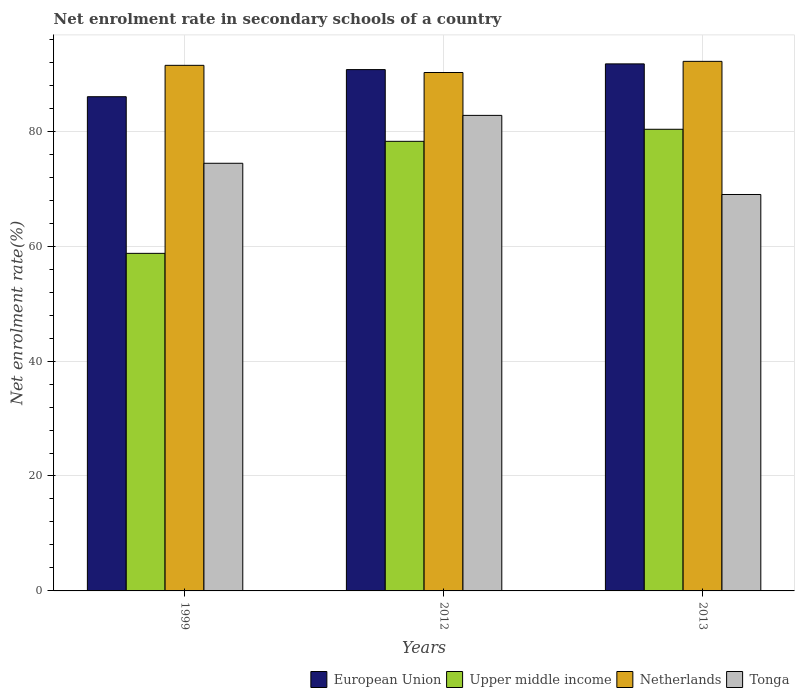How many different coloured bars are there?
Provide a short and direct response. 4. Are the number of bars per tick equal to the number of legend labels?
Make the answer very short. Yes. Are the number of bars on each tick of the X-axis equal?
Your answer should be compact. Yes. How many bars are there on the 3rd tick from the right?
Ensure brevity in your answer.  4. What is the label of the 1st group of bars from the left?
Provide a succinct answer. 1999. What is the net enrolment rate in secondary schools in Tonga in 2012?
Keep it short and to the point. 82.76. Across all years, what is the maximum net enrolment rate in secondary schools in European Union?
Keep it short and to the point. 91.72. Across all years, what is the minimum net enrolment rate in secondary schools in Tonga?
Make the answer very short. 68.99. In which year was the net enrolment rate in secondary schools in Netherlands maximum?
Offer a very short reply. 2013. In which year was the net enrolment rate in secondary schools in European Union minimum?
Give a very brief answer. 1999. What is the total net enrolment rate in secondary schools in Tonga in the graph?
Give a very brief answer. 226.17. What is the difference between the net enrolment rate in secondary schools in Netherlands in 2012 and that in 2013?
Your response must be concise. -1.94. What is the difference between the net enrolment rate in secondary schools in European Union in 2012 and the net enrolment rate in secondary schools in Upper middle income in 2013?
Give a very brief answer. 10.38. What is the average net enrolment rate in secondary schools in Upper middle income per year?
Offer a very short reply. 72.44. In the year 2013, what is the difference between the net enrolment rate in secondary schools in Tonga and net enrolment rate in secondary schools in Netherlands?
Give a very brief answer. -23.17. What is the ratio of the net enrolment rate in secondary schools in Tonga in 2012 to that in 2013?
Give a very brief answer. 1.2. Is the net enrolment rate in secondary schools in Tonga in 2012 less than that in 2013?
Offer a terse response. No. Is the difference between the net enrolment rate in secondary schools in Tonga in 2012 and 2013 greater than the difference between the net enrolment rate in secondary schools in Netherlands in 2012 and 2013?
Your answer should be very brief. Yes. What is the difference between the highest and the second highest net enrolment rate in secondary schools in European Union?
Your response must be concise. 0.99. What is the difference between the highest and the lowest net enrolment rate in secondary schools in Tonga?
Your answer should be very brief. 13.77. In how many years, is the net enrolment rate in secondary schools in Tonga greater than the average net enrolment rate in secondary schools in Tonga taken over all years?
Offer a very short reply. 1. What does the 1st bar from the right in 2013 represents?
Make the answer very short. Tonga. How many years are there in the graph?
Make the answer very short. 3. What is the difference between two consecutive major ticks on the Y-axis?
Ensure brevity in your answer.  20. Does the graph contain grids?
Your response must be concise. Yes. What is the title of the graph?
Your answer should be very brief. Net enrolment rate in secondary schools of a country. Does "Kyrgyz Republic" appear as one of the legend labels in the graph?
Provide a succinct answer. No. What is the label or title of the Y-axis?
Offer a terse response. Net enrolment rate(%). What is the Net enrolment rate(%) of European Union in 1999?
Your response must be concise. 86.01. What is the Net enrolment rate(%) of Upper middle income in 1999?
Provide a succinct answer. 58.75. What is the Net enrolment rate(%) of Netherlands in 1999?
Keep it short and to the point. 91.47. What is the Net enrolment rate(%) in Tonga in 1999?
Provide a short and direct response. 74.42. What is the Net enrolment rate(%) of European Union in 2012?
Keep it short and to the point. 90.73. What is the Net enrolment rate(%) in Upper middle income in 2012?
Your answer should be very brief. 78.24. What is the Net enrolment rate(%) in Netherlands in 2012?
Your response must be concise. 90.22. What is the Net enrolment rate(%) in Tonga in 2012?
Keep it short and to the point. 82.76. What is the Net enrolment rate(%) of European Union in 2013?
Your answer should be very brief. 91.72. What is the Net enrolment rate(%) in Upper middle income in 2013?
Offer a very short reply. 80.34. What is the Net enrolment rate(%) in Netherlands in 2013?
Ensure brevity in your answer.  92.16. What is the Net enrolment rate(%) of Tonga in 2013?
Your answer should be very brief. 68.99. Across all years, what is the maximum Net enrolment rate(%) in European Union?
Your response must be concise. 91.72. Across all years, what is the maximum Net enrolment rate(%) in Upper middle income?
Your answer should be very brief. 80.34. Across all years, what is the maximum Net enrolment rate(%) in Netherlands?
Make the answer very short. 92.16. Across all years, what is the maximum Net enrolment rate(%) of Tonga?
Offer a terse response. 82.76. Across all years, what is the minimum Net enrolment rate(%) in European Union?
Offer a terse response. 86.01. Across all years, what is the minimum Net enrolment rate(%) of Upper middle income?
Your answer should be very brief. 58.75. Across all years, what is the minimum Net enrolment rate(%) of Netherlands?
Make the answer very short. 90.22. Across all years, what is the minimum Net enrolment rate(%) of Tonga?
Offer a very short reply. 68.99. What is the total Net enrolment rate(%) in European Union in the graph?
Offer a very short reply. 268.45. What is the total Net enrolment rate(%) in Upper middle income in the graph?
Make the answer very short. 217.33. What is the total Net enrolment rate(%) in Netherlands in the graph?
Offer a terse response. 273.84. What is the total Net enrolment rate(%) in Tonga in the graph?
Your answer should be compact. 226.17. What is the difference between the Net enrolment rate(%) in European Union in 1999 and that in 2012?
Offer a very short reply. -4.72. What is the difference between the Net enrolment rate(%) of Upper middle income in 1999 and that in 2012?
Provide a succinct answer. -19.5. What is the difference between the Net enrolment rate(%) of Netherlands in 1999 and that in 2012?
Give a very brief answer. 1.25. What is the difference between the Net enrolment rate(%) in Tonga in 1999 and that in 2012?
Your answer should be compact. -8.34. What is the difference between the Net enrolment rate(%) in European Union in 1999 and that in 2013?
Your response must be concise. -5.71. What is the difference between the Net enrolment rate(%) of Upper middle income in 1999 and that in 2013?
Give a very brief answer. -21.59. What is the difference between the Net enrolment rate(%) of Netherlands in 1999 and that in 2013?
Offer a very short reply. -0.69. What is the difference between the Net enrolment rate(%) in Tonga in 1999 and that in 2013?
Your response must be concise. 5.43. What is the difference between the Net enrolment rate(%) of European Union in 2012 and that in 2013?
Keep it short and to the point. -0.99. What is the difference between the Net enrolment rate(%) in Upper middle income in 2012 and that in 2013?
Your answer should be very brief. -2.1. What is the difference between the Net enrolment rate(%) in Netherlands in 2012 and that in 2013?
Make the answer very short. -1.94. What is the difference between the Net enrolment rate(%) of Tonga in 2012 and that in 2013?
Ensure brevity in your answer.  13.77. What is the difference between the Net enrolment rate(%) in European Union in 1999 and the Net enrolment rate(%) in Upper middle income in 2012?
Provide a short and direct response. 7.76. What is the difference between the Net enrolment rate(%) in European Union in 1999 and the Net enrolment rate(%) in Netherlands in 2012?
Provide a succinct answer. -4.21. What is the difference between the Net enrolment rate(%) of Upper middle income in 1999 and the Net enrolment rate(%) of Netherlands in 2012?
Offer a very short reply. -31.47. What is the difference between the Net enrolment rate(%) in Upper middle income in 1999 and the Net enrolment rate(%) in Tonga in 2012?
Give a very brief answer. -24.01. What is the difference between the Net enrolment rate(%) in Netherlands in 1999 and the Net enrolment rate(%) in Tonga in 2012?
Provide a short and direct response. 8.71. What is the difference between the Net enrolment rate(%) of European Union in 1999 and the Net enrolment rate(%) of Upper middle income in 2013?
Your response must be concise. 5.67. What is the difference between the Net enrolment rate(%) of European Union in 1999 and the Net enrolment rate(%) of Netherlands in 2013?
Ensure brevity in your answer.  -6.15. What is the difference between the Net enrolment rate(%) of European Union in 1999 and the Net enrolment rate(%) of Tonga in 2013?
Keep it short and to the point. 17.02. What is the difference between the Net enrolment rate(%) of Upper middle income in 1999 and the Net enrolment rate(%) of Netherlands in 2013?
Offer a very short reply. -33.41. What is the difference between the Net enrolment rate(%) of Upper middle income in 1999 and the Net enrolment rate(%) of Tonga in 2013?
Provide a succinct answer. -10.24. What is the difference between the Net enrolment rate(%) in Netherlands in 1999 and the Net enrolment rate(%) in Tonga in 2013?
Your answer should be compact. 22.47. What is the difference between the Net enrolment rate(%) in European Union in 2012 and the Net enrolment rate(%) in Upper middle income in 2013?
Provide a short and direct response. 10.38. What is the difference between the Net enrolment rate(%) in European Union in 2012 and the Net enrolment rate(%) in Netherlands in 2013?
Your answer should be very brief. -1.43. What is the difference between the Net enrolment rate(%) in European Union in 2012 and the Net enrolment rate(%) in Tonga in 2013?
Your answer should be very brief. 21.73. What is the difference between the Net enrolment rate(%) in Upper middle income in 2012 and the Net enrolment rate(%) in Netherlands in 2013?
Your response must be concise. -13.92. What is the difference between the Net enrolment rate(%) of Upper middle income in 2012 and the Net enrolment rate(%) of Tonga in 2013?
Your answer should be compact. 9.25. What is the difference between the Net enrolment rate(%) in Netherlands in 2012 and the Net enrolment rate(%) in Tonga in 2013?
Offer a terse response. 21.23. What is the average Net enrolment rate(%) in European Union per year?
Make the answer very short. 89.48. What is the average Net enrolment rate(%) in Upper middle income per year?
Offer a very short reply. 72.44. What is the average Net enrolment rate(%) of Netherlands per year?
Your answer should be compact. 91.28. What is the average Net enrolment rate(%) in Tonga per year?
Your answer should be very brief. 75.39. In the year 1999, what is the difference between the Net enrolment rate(%) of European Union and Net enrolment rate(%) of Upper middle income?
Your answer should be compact. 27.26. In the year 1999, what is the difference between the Net enrolment rate(%) of European Union and Net enrolment rate(%) of Netherlands?
Keep it short and to the point. -5.46. In the year 1999, what is the difference between the Net enrolment rate(%) in European Union and Net enrolment rate(%) in Tonga?
Provide a succinct answer. 11.59. In the year 1999, what is the difference between the Net enrolment rate(%) in Upper middle income and Net enrolment rate(%) in Netherlands?
Give a very brief answer. -32.72. In the year 1999, what is the difference between the Net enrolment rate(%) in Upper middle income and Net enrolment rate(%) in Tonga?
Keep it short and to the point. -15.67. In the year 1999, what is the difference between the Net enrolment rate(%) in Netherlands and Net enrolment rate(%) in Tonga?
Give a very brief answer. 17.04. In the year 2012, what is the difference between the Net enrolment rate(%) of European Union and Net enrolment rate(%) of Upper middle income?
Your answer should be very brief. 12.48. In the year 2012, what is the difference between the Net enrolment rate(%) in European Union and Net enrolment rate(%) in Netherlands?
Your answer should be very brief. 0.51. In the year 2012, what is the difference between the Net enrolment rate(%) in European Union and Net enrolment rate(%) in Tonga?
Your answer should be compact. 7.97. In the year 2012, what is the difference between the Net enrolment rate(%) in Upper middle income and Net enrolment rate(%) in Netherlands?
Provide a succinct answer. -11.97. In the year 2012, what is the difference between the Net enrolment rate(%) in Upper middle income and Net enrolment rate(%) in Tonga?
Ensure brevity in your answer.  -4.51. In the year 2012, what is the difference between the Net enrolment rate(%) of Netherlands and Net enrolment rate(%) of Tonga?
Make the answer very short. 7.46. In the year 2013, what is the difference between the Net enrolment rate(%) of European Union and Net enrolment rate(%) of Upper middle income?
Ensure brevity in your answer.  11.38. In the year 2013, what is the difference between the Net enrolment rate(%) in European Union and Net enrolment rate(%) in Netherlands?
Your response must be concise. -0.44. In the year 2013, what is the difference between the Net enrolment rate(%) in European Union and Net enrolment rate(%) in Tonga?
Ensure brevity in your answer.  22.73. In the year 2013, what is the difference between the Net enrolment rate(%) in Upper middle income and Net enrolment rate(%) in Netherlands?
Provide a succinct answer. -11.82. In the year 2013, what is the difference between the Net enrolment rate(%) in Upper middle income and Net enrolment rate(%) in Tonga?
Your response must be concise. 11.35. In the year 2013, what is the difference between the Net enrolment rate(%) of Netherlands and Net enrolment rate(%) of Tonga?
Provide a succinct answer. 23.17. What is the ratio of the Net enrolment rate(%) in European Union in 1999 to that in 2012?
Make the answer very short. 0.95. What is the ratio of the Net enrolment rate(%) of Upper middle income in 1999 to that in 2012?
Your answer should be compact. 0.75. What is the ratio of the Net enrolment rate(%) of Netherlands in 1999 to that in 2012?
Ensure brevity in your answer.  1.01. What is the ratio of the Net enrolment rate(%) of Tonga in 1999 to that in 2012?
Offer a very short reply. 0.9. What is the ratio of the Net enrolment rate(%) of European Union in 1999 to that in 2013?
Keep it short and to the point. 0.94. What is the ratio of the Net enrolment rate(%) in Upper middle income in 1999 to that in 2013?
Keep it short and to the point. 0.73. What is the ratio of the Net enrolment rate(%) in Tonga in 1999 to that in 2013?
Offer a very short reply. 1.08. What is the ratio of the Net enrolment rate(%) in Upper middle income in 2012 to that in 2013?
Offer a very short reply. 0.97. What is the ratio of the Net enrolment rate(%) of Netherlands in 2012 to that in 2013?
Give a very brief answer. 0.98. What is the ratio of the Net enrolment rate(%) of Tonga in 2012 to that in 2013?
Your answer should be compact. 1.2. What is the difference between the highest and the second highest Net enrolment rate(%) in European Union?
Make the answer very short. 0.99. What is the difference between the highest and the second highest Net enrolment rate(%) of Upper middle income?
Offer a terse response. 2.1. What is the difference between the highest and the second highest Net enrolment rate(%) in Netherlands?
Your answer should be very brief. 0.69. What is the difference between the highest and the second highest Net enrolment rate(%) in Tonga?
Give a very brief answer. 8.34. What is the difference between the highest and the lowest Net enrolment rate(%) of European Union?
Your answer should be very brief. 5.71. What is the difference between the highest and the lowest Net enrolment rate(%) of Upper middle income?
Offer a terse response. 21.59. What is the difference between the highest and the lowest Net enrolment rate(%) in Netherlands?
Offer a very short reply. 1.94. What is the difference between the highest and the lowest Net enrolment rate(%) of Tonga?
Provide a succinct answer. 13.77. 